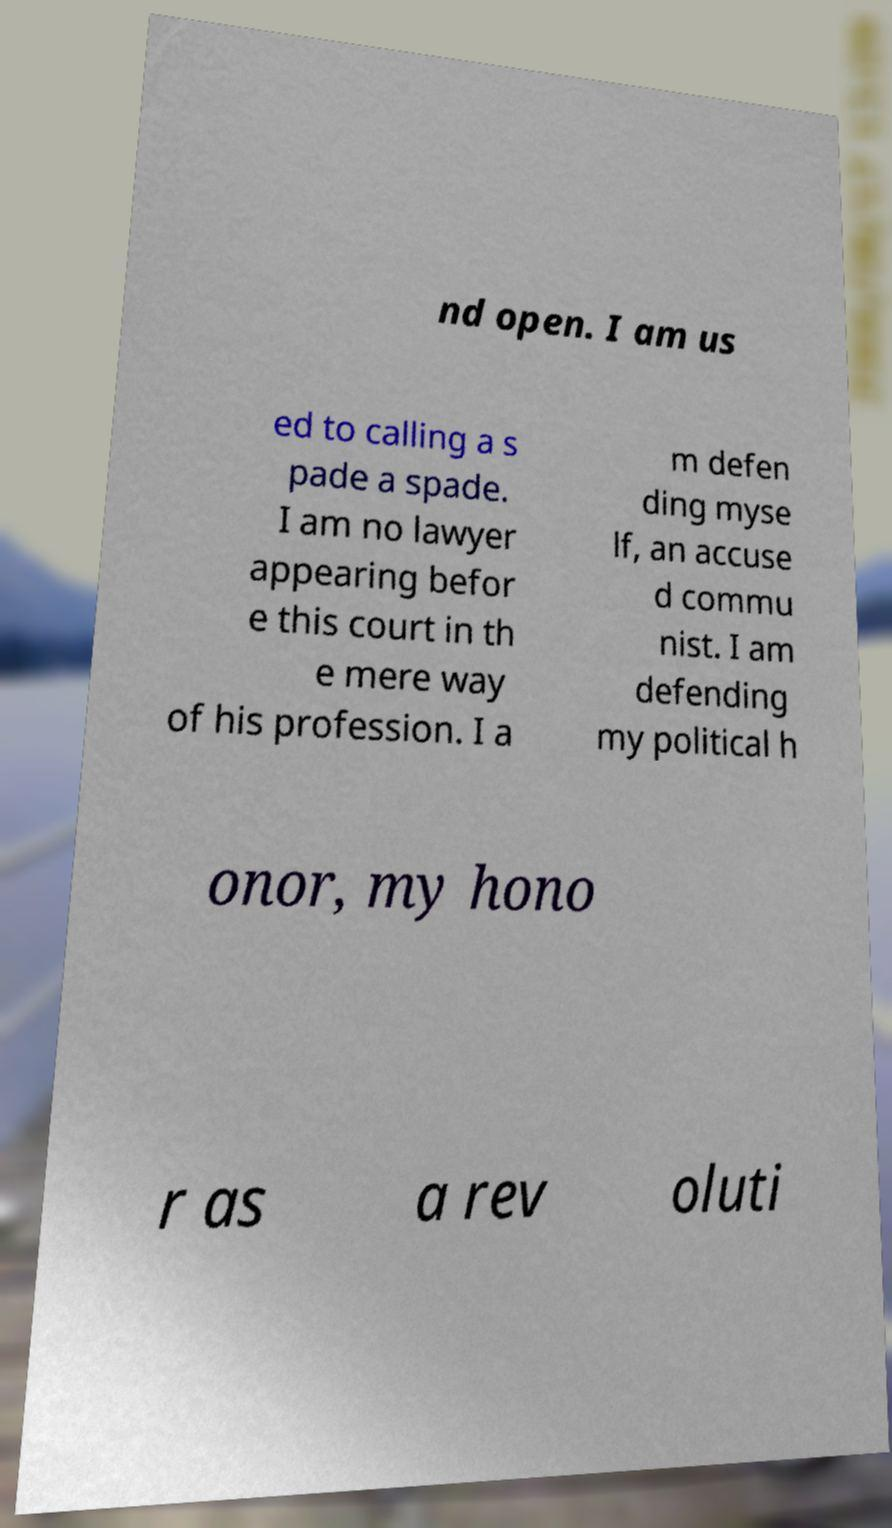Could you assist in decoding the text presented in this image and type it out clearly? nd open. I am us ed to calling a s pade a spade. I am no lawyer appearing befor e this court in th e mere way of his profession. I a m defen ding myse lf, an accuse d commu nist. I am defending my political h onor, my hono r as a rev oluti 